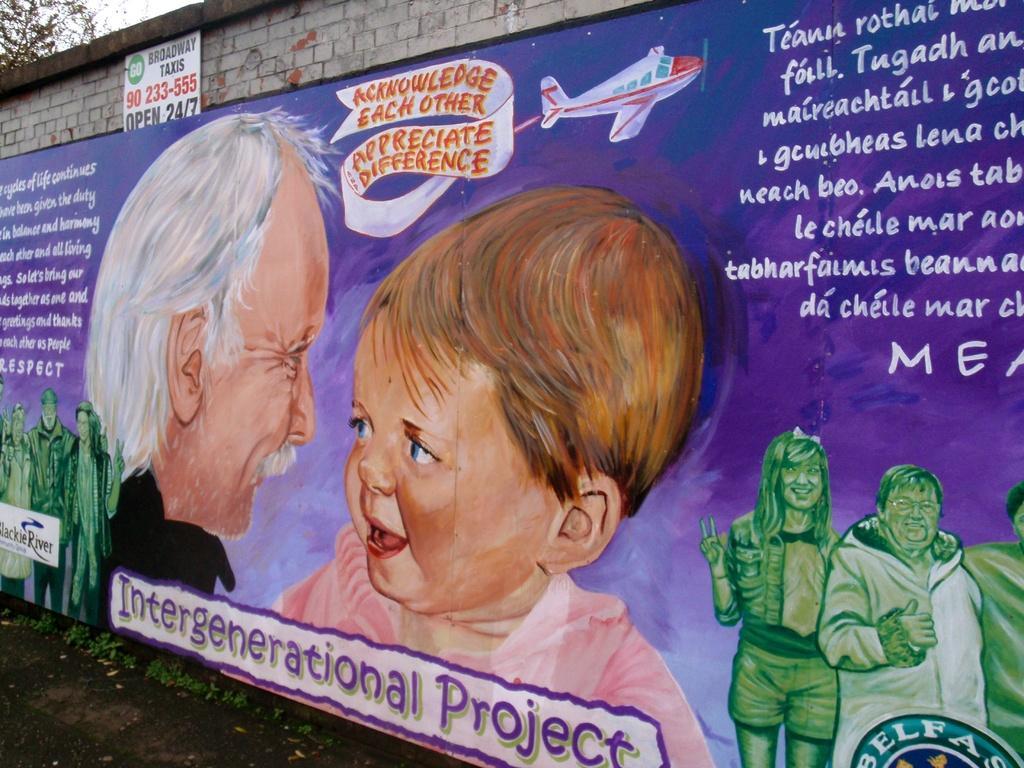Describe this image in one or two sentences. In this image there is a banner with some text written on it and there are images of the persons on the banner. In the background there is a wall and there is a tree. 